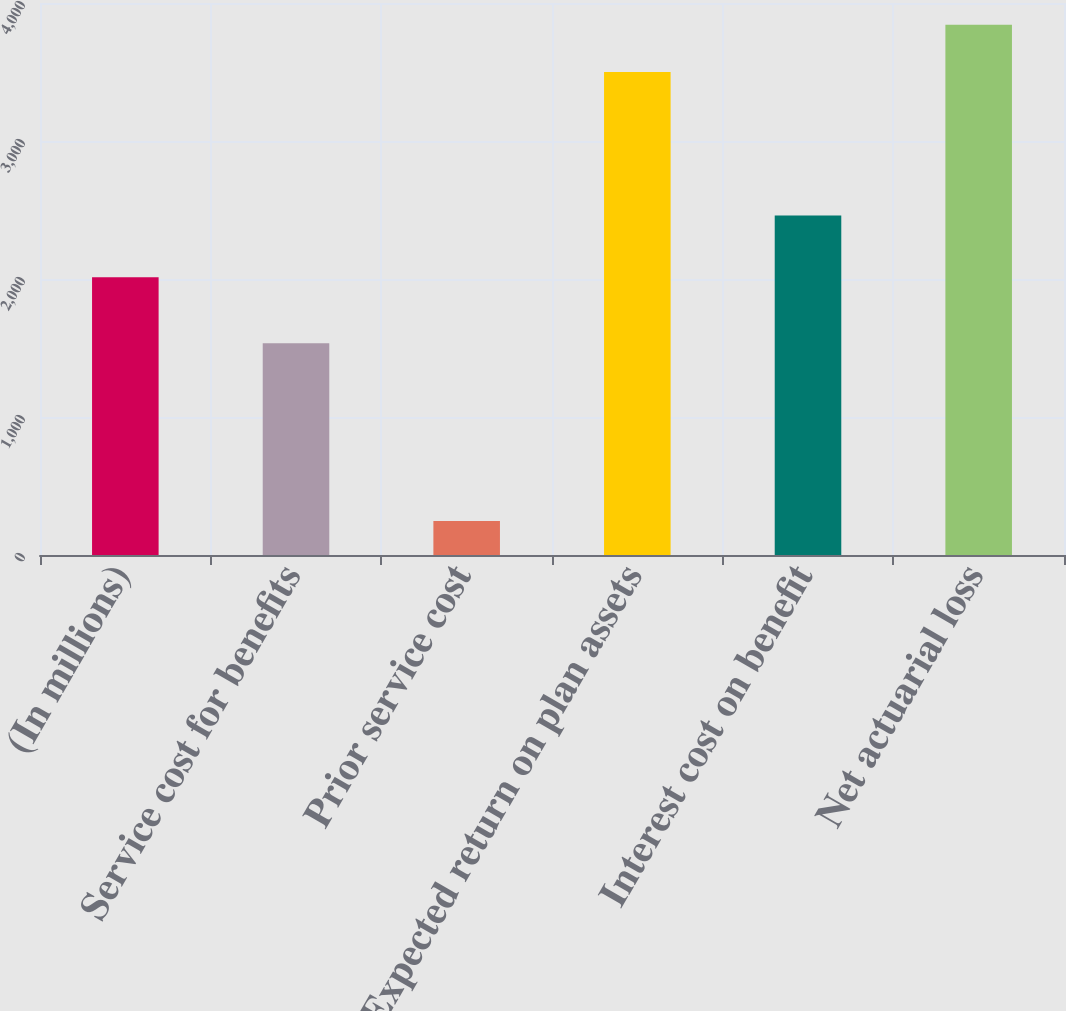Convert chart to OTSL. <chart><loc_0><loc_0><loc_500><loc_500><bar_chart><fcel>(In millions)<fcel>Service cost for benefits<fcel>Prior service cost<fcel>Expected return on plan assets<fcel>Interest cost on benefit<fcel>Net actuarial loss<nl><fcel>2013<fcel>1535<fcel>246<fcel>3500<fcel>2460<fcel>3841.8<nl></chart> 